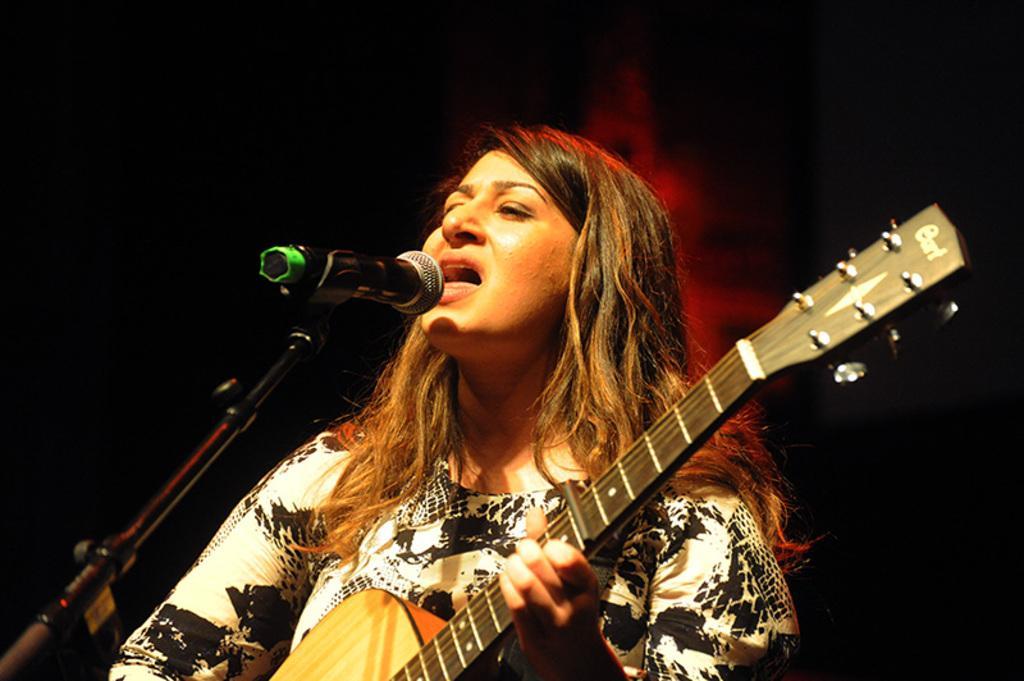Describe this image in one or two sentences. One woman is standing in white and black dress and playing a guitar and she is singing in front of the microphone. 